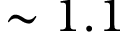Convert formula to latex. <formula><loc_0><loc_0><loc_500><loc_500>\sim 1 . 1</formula> 